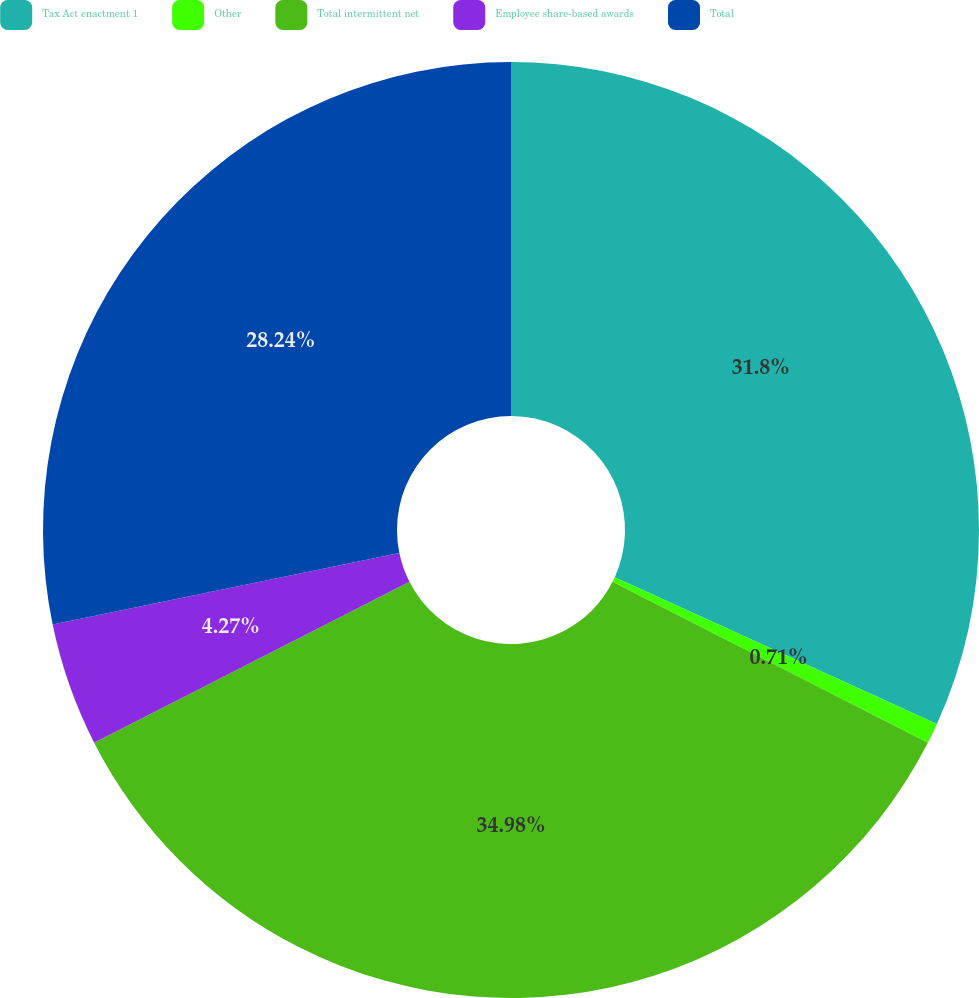<chart> <loc_0><loc_0><loc_500><loc_500><pie_chart><fcel>Tax Act enactment 1<fcel>Other<fcel>Total intermittent net<fcel>Employee share-based awards<fcel>Total<nl><fcel>31.8%<fcel>0.71%<fcel>34.98%<fcel>4.27%<fcel>28.24%<nl></chart> 